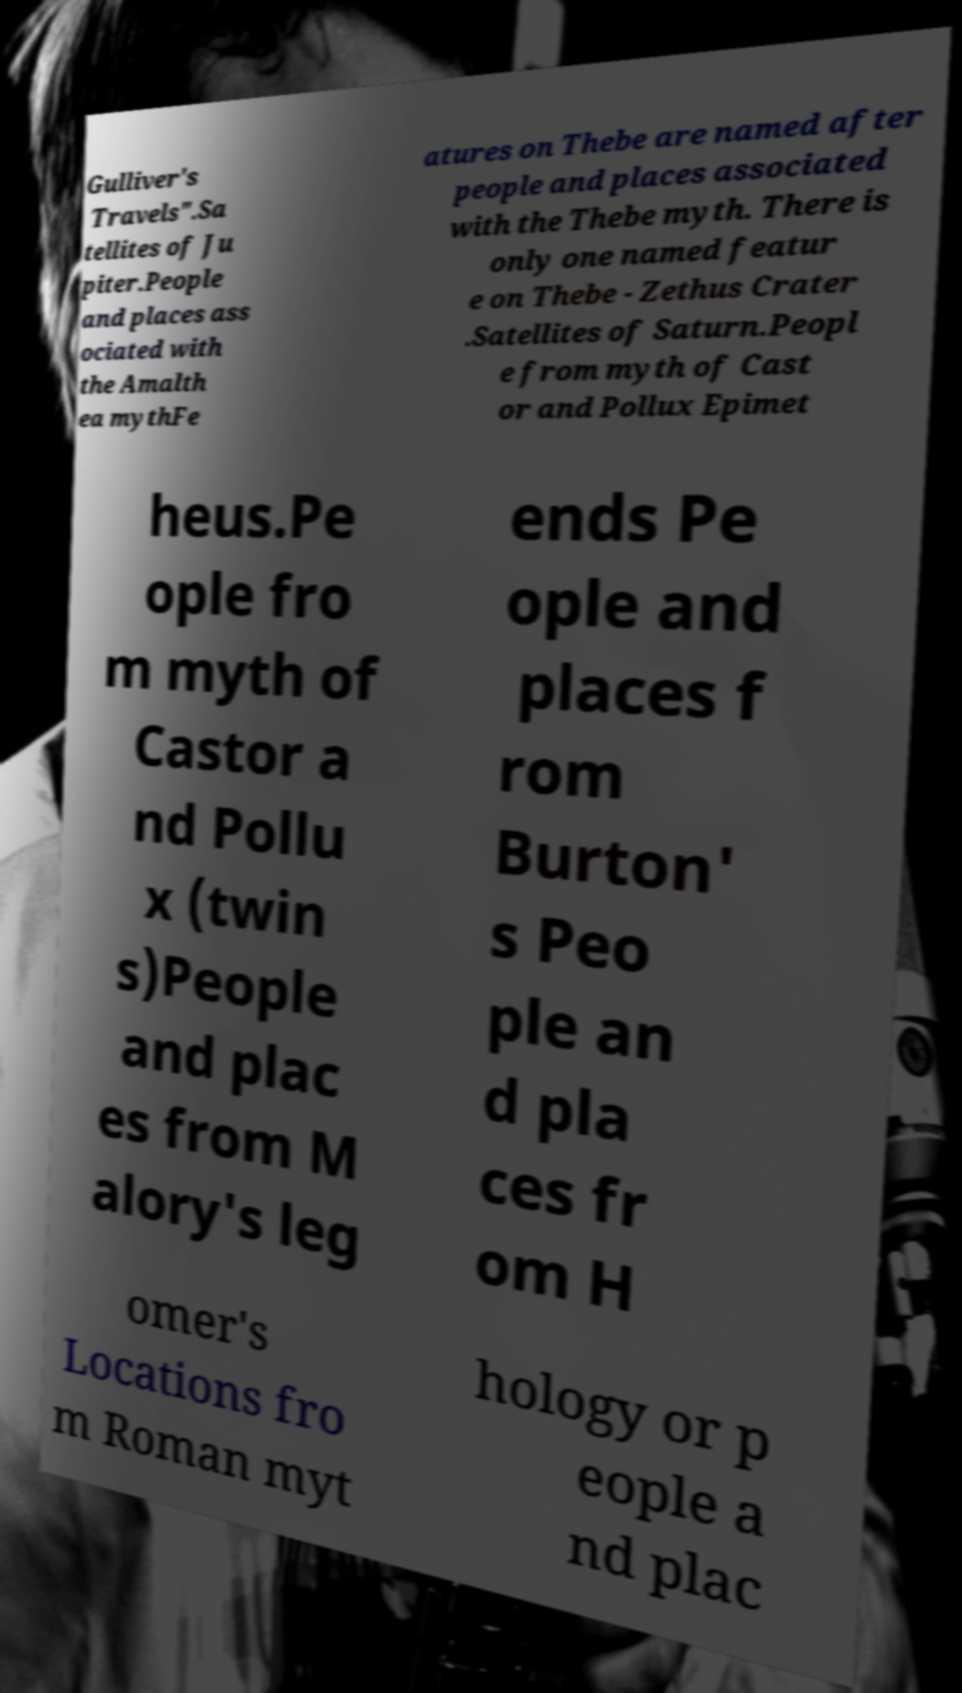There's text embedded in this image that I need extracted. Can you transcribe it verbatim? Gulliver's Travels".Sa tellites of Ju piter.People and places ass ociated with the Amalth ea mythFe atures on Thebe are named after people and places associated with the Thebe myth. There is only one named featur e on Thebe - Zethus Crater .Satellites of Saturn.Peopl e from myth of Cast or and Pollux Epimet heus.Pe ople fro m myth of Castor a nd Pollu x (twin s)People and plac es from M alory's leg ends Pe ople and places f rom Burton' s Peo ple an d pla ces fr om H omer's Locations fro m Roman myt hology or p eople a nd plac 